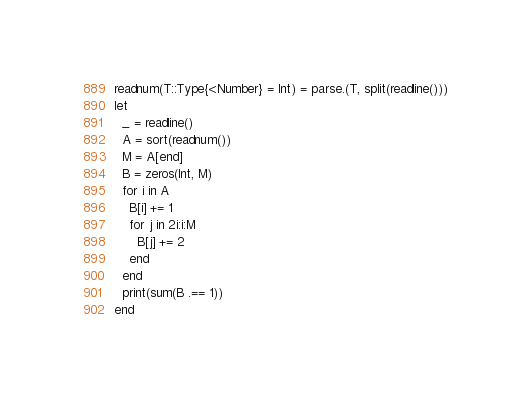<code> <loc_0><loc_0><loc_500><loc_500><_Julia_>readnum(T::Type{<:Number} = Int) = parse.(T, split(readline()))
let
  _ = readline()
  A = sort(readnum())
  M = A[end]
  B = zeros(Int, M)
  for i in A
    B[i] += 1
    for j in 2i:i:M
      B[j] += 2
    end
  end
  print(sum(B .== 1))
end
</code> 